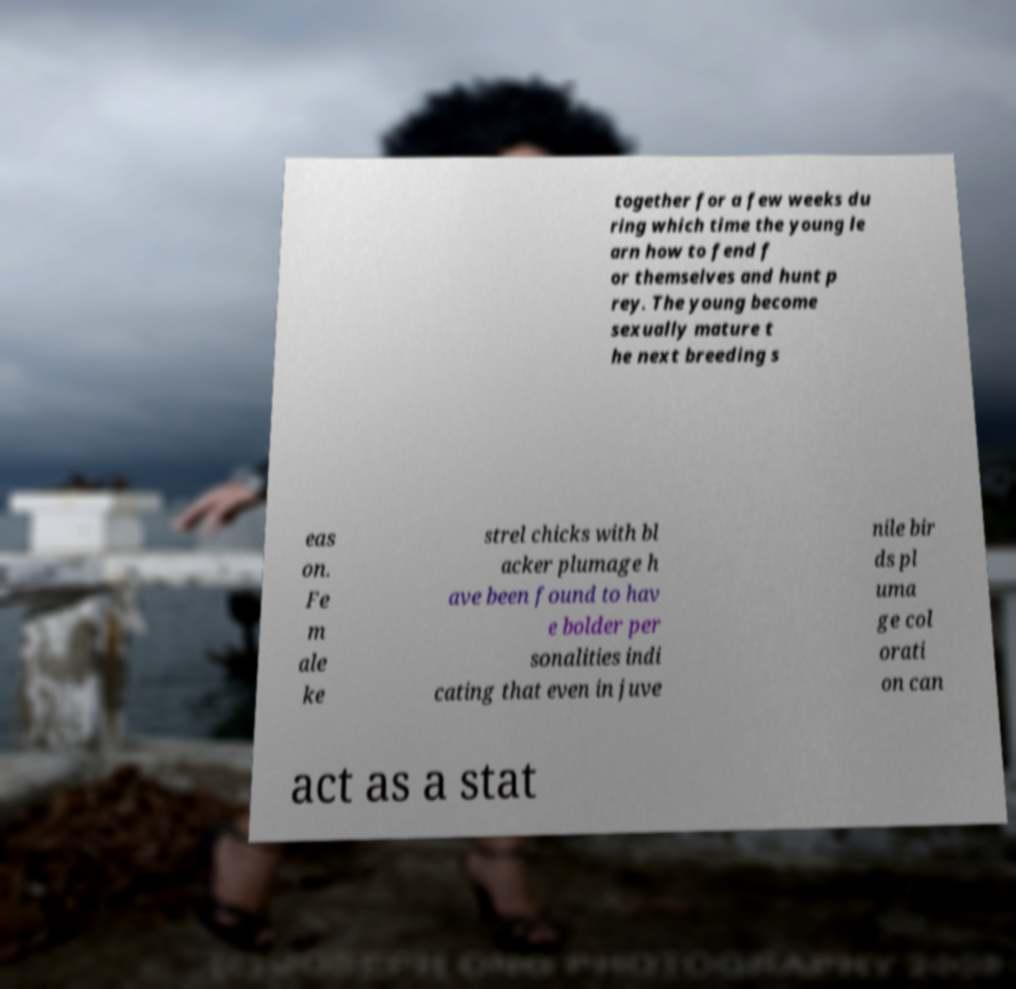Can you accurately transcribe the text from the provided image for me? together for a few weeks du ring which time the young le arn how to fend f or themselves and hunt p rey. The young become sexually mature t he next breeding s eas on. Fe m ale ke strel chicks with bl acker plumage h ave been found to hav e bolder per sonalities indi cating that even in juve nile bir ds pl uma ge col orati on can act as a stat 